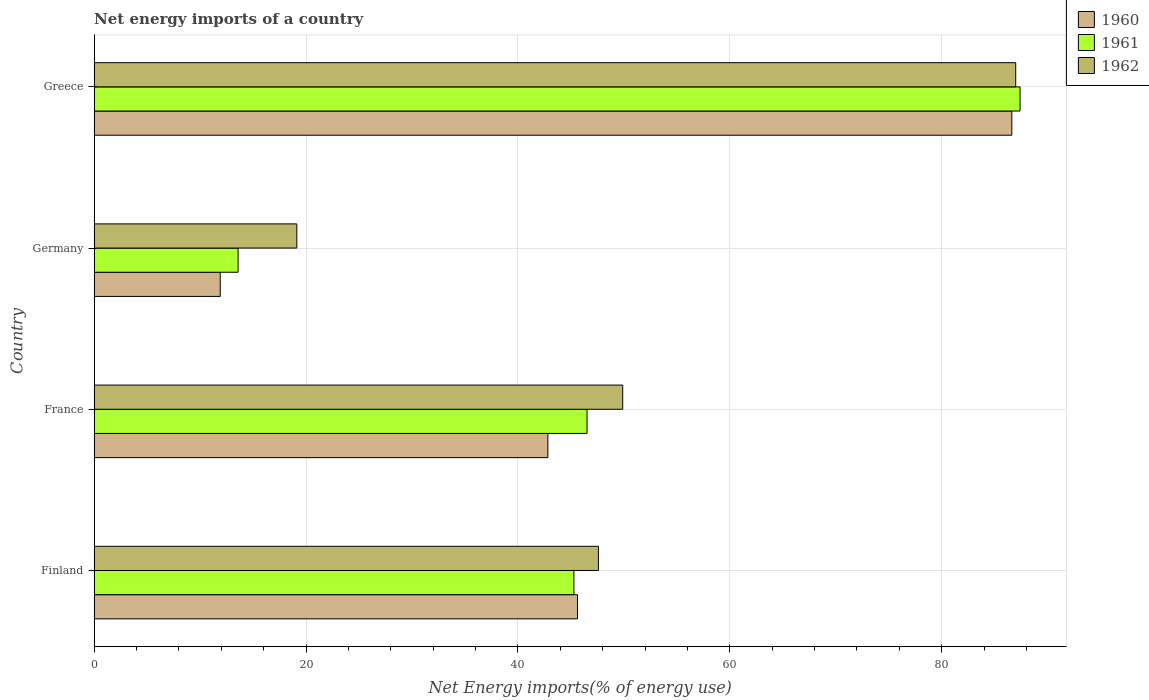How many different coloured bars are there?
Your answer should be compact. 3. How many groups of bars are there?
Make the answer very short. 4. Are the number of bars per tick equal to the number of legend labels?
Give a very brief answer. Yes. Are the number of bars on each tick of the Y-axis equal?
Your answer should be compact. Yes. How many bars are there on the 3rd tick from the top?
Ensure brevity in your answer.  3. In how many cases, is the number of bars for a given country not equal to the number of legend labels?
Your answer should be very brief. 0. What is the net energy imports in 1961 in Finland?
Your answer should be compact. 45.28. Across all countries, what is the maximum net energy imports in 1962?
Offer a very short reply. 86.98. Across all countries, what is the minimum net energy imports in 1961?
Provide a succinct answer. 13.58. In which country was the net energy imports in 1960 maximum?
Ensure brevity in your answer.  Greece. In which country was the net energy imports in 1960 minimum?
Your response must be concise. Germany. What is the total net energy imports in 1960 in the graph?
Provide a succinct answer. 186.96. What is the difference between the net energy imports in 1961 in France and that in Greece?
Ensure brevity in your answer.  -40.87. What is the difference between the net energy imports in 1962 in France and the net energy imports in 1961 in Finland?
Provide a succinct answer. 4.61. What is the average net energy imports in 1960 per country?
Make the answer very short. 46.74. What is the difference between the net energy imports in 1960 and net energy imports in 1962 in Finland?
Provide a short and direct response. -1.97. In how many countries, is the net energy imports in 1961 greater than 24 %?
Your response must be concise. 3. What is the ratio of the net energy imports in 1962 in France to that in Greece?
Offer a very short reply. 0.57. What is the difference between the highest and the second highest net energy imports in 1960?
Offer a very short reply. 41. What is the difference between the highest and the lowest net energy imports in 1961?
Offer a terse response. 73.81. What does the 3rd bar from the top in Germany represents?
Your answer should be very brief. 1960. Is it the case that in every country, the sum of the net energy imports in 1960 and net energy imports in 1961 is greater than the net energy imports in 1962?
Your answer should be compact. Yes. Are all the bars in the graph horizontal?
Provide a succinct answer. Yes. How many countries are there in the graph?
Give a very brief answer. 4. What is the difference between two consecutive major ticks on the X-axis?
Provide a short and direct response. 20. Are the values on the major ticks of X-axis written in scientific E-notation?
Ensure brevity in your answer.  No. Does the graph contain any zero values?
Offer a very short reply. No. Does the graph contain grids?
Offer a very short reply. Yes. How are the legend labels stacked?
Ensure brevity in your answer.  Vertical. What is the title of the graph?
Offer a very short reply. Net energy imports of a country. Does "1976" appear as one of the legend labels in the graph?
Give a very brief answer. No. What is the label or title of the X-axis?
Provide a short and direct response. Net Energy imports(% of energy use). What is the label or title of the Y-axis?
Offer a very short reply. Country. What is the Net Energy imports(% of energy use) of 1960 in Finland?
Offer a terse response. 45.62. What is the Net Energy imports(% of energy use) in 1961 in Finland?
Your answer should be compact. 45.28. What is the Net Energy imports(% of energy use) of 1962 in Finland?
Your answer should be compact. 47.59. What is the Net Energy imports(% of energy use) in 1960 in France?
Ensure brevity in your answer.  42.82. What is the Net Energy imports(% of energy use) in 1961 in France?
Make the answer very short. 46.52. What is the Net Energy imports(% of energy use) of 1962 in France?
Offer a terse response. 49.89. What is the Net Energy imports(% of energy use) in 1960 in Germany?
Your answer should be compact. 11.9. What is the Net Energy imports(% of energy use) of 1961 in Germany?
Your answer should be compact. 13.58. What is the Net Energy imports(% of energy use) in 1962 in Germany?
Keep it short and to the point. 19.13. What is the Net Energy imports(% of energy use) of 1960 in Greece?
Offer a terse response. 86.62. What is the Net Energy imports(% of energy use) in 1961 in Greece?
Offer a terse response. 87.4. What is the Net Energy imports(% of energy use) in 1962 in Greece?
Provide a short and direct response. 86.98. Across all countries, what is the maximum Net Energy imports(% of energy use) of 1960?
Provide a short and direct response. 86.62. Across all countries, what is the maximum Net Energy imports(% of energy use) in 1961?
Provide a succinct answer. 87.4. Across all countries, what is the maximum Net Energy imports(% of energy use) in 1962?
Offer a very short reply. 86.98. Across all countries, what is the minimum Net Energy imports(% of energy use) of 1960?
Keep it short and to the point. 11.9. Across all countries, what is the minimum Net Energy imports(% of energy use) in 1961?
Your response must be concise. 13.58. Across all countries, what is the minimum Net Energy imports(% of energy use) of 1962?
Your answer should be very brief. 19.13. What is the total Net Energy imports(% of energy use) of 1960 in the graph?
Your answer should be very brief. 186.96. What is the total Net Energy imports(% of energy use) in 1961 in the graph?
Give a very brief answer. 192.78. What is the total Net Energy imports(% of energy use) in 1962 in the graph?
Provide a short and direct response. 203.59. What is the difference between the Net Energy imports(% of energy use) of 1960 in Finland and that in France?
Your answer should be compact. 2.8. What is the difference between the Net Energy imports(% of energy use) of 1961 in Finland and that in France?
Your answer should be compact. -1.24. What is the difference between the Net Energy imports(% of energy use) in 1962 in Finland and that in France?
Give a very brief answer. -2.3. What is the difference between the Net Energy imports(% of energy use) of 1960 in Finland and that in Germany?
Make the answer very short. 33.72. What is the difference between the Net Energy imports(% of energy use) of 1961 in Finland and that in Germany?
Keep it short and to the point. 31.7. What is the difference between the Net Energy imports(% of energy use) in 1962 in Finland and that in Germany?
Your answer should be compact. 28.47. What is the difference between the Net Energy imports(% of energy use) in 1960 in Finland and that in Greece?
Your response must be concise. -41. What is the difference between the Net Energy imports(% of energy use) in 1961 in Finland and that in Greece?
Your response must be concise. -42.12. What is the difference between the Net Energy imports(% of energy use) of 1962 in Finland and that in Greece?
Offer a terse response. -39.39. What is the difference between the Net Energy imports(% of energy use) in 1960 in France and that in Germany?
Give a very brief answer. 30.93. What is the difference between the Net Energy imports(% of energy use) in 1961 in France and that in Germany?
Offer a terse response. 32.94. What is the difference between the Net Energy imports(% of energy use) in 1962 in France and that in Germany?
Provide a succinct answer. 30.76. What is the difference between the Net Energy imports(% of energy use) of 1960 in France and that in Greece?
Provide a succinct answer. -43.79. What is the difference between the Net Energy imports(% of energy use) in 1961 in France and that in Greece?
Offer a terse response. -40.87. What is the difference between the Net Energy imports(% of energy use) in 1962 in France and that in Greece?
Your answer should be very brief. -37.09. What is the difference between the Net Energy imports(% of energy use) of 1960 in Germany and that in Greece?
Offer a very short reply. -74.72. What is the difference between the Net Energy imports(% of energy use) of 1961 in Germany and that in Greece?
Your answer should be very brief. -73.81. What is the difference between the Net Energy imports(% of energy use) in 1962 in Germany and that in Greece?
Keep it short and to the point. -67.86. What is the difference between the Net Energy imports(% of energy use) of 1960 in Finland and the Net Energy imports(% of energy use) of 1961 in France?
Your response must be concise. -0.9. What is the difference between the Net Energy imports(% of energy use) of 1960 in Finland and the Net Energy imports(% of energy use) of 1962 in France?
Your response must be concise. -4.27. What is the difference between the Net Energy imports(% of energy use) of 1961 in Finland and the Net Energy imports(% of energy use) of 1962 in France?
Make the answer very short. -4.61. What is the difference between the Net Energy imports(% of energy use) in 1960 in Finland and the Net Energy imports(% of energy use) in 1961 in Germany?
Your answer should be compact. 32.04. What is the difference between the Net Energy imports(% of energy use) in 1960 in Finland and the Net Energy imports(% of energy use) in 1962 in Germany?
Keep it short and to the point. 26.49. What is the difference between the Net Energy imports(% of energy use) of 1961 in Finland and the Net Energy imports(% of energy use) of 1962 in Germany?
Your answer should be very brief. 26.15. What is the difference between the Net Energy imports(% of energy use) in 1960 in Finland and the Net Energy imports(% of energy use) in 1961 in Greece?
Offer a terse response. -41.78. What is the difference between the Net Energy imports(% of energy use) of 1960 in Finland and the Net Energy imports(% of energy use) of 1962 in Greece?
Ensure brevity in your answer.  -41.36. What is the difference between the Net Energy imports(% of energy use) of 1961 in Finland and the Net Energy imports(% of energy use) of 1962 in Greece?
Offer a terse response. -41.7. What is the difference between the Net Energy imports(% of energy use) of 1960 in France and the Net Energy imports(% of energy use) of 1961 in Germany?
Your response must be concise. 29.24. What is the difference between the Net Energy imports(% of energy use) of 1960 in France and the Net Energy imports(% of energy use) of 1962 in Germany?
Keep it short and to the point. 23.7. What is the difference between the Net Energy imports(% of energy use) in 1961 in France and the Net Energy imports(% of energy use) in 1962 in Germany?
Provide a succinct answer. 27.39. What is the difference between the Net Energy imports(% of energy use) of 1960 in France and the Net Energy imports(% of energy use) of 1961 in Greece?
Your answer should be very brief. -44.57. What is the difference between the Net Energy imports(% of energy use) in 1960 in France and the Net Energy imports(% of energy use) in 1962 in Greece?
Give a very brief answer. -44.16. What is the difference between the Net Energy imports(% of energy use) in 1961 in France and the Net Energy imports(% of energy use) in 1962 in Greece?
Keep it short and to the point. -40.46. What is the difference between the Net Energy imports(% of energy use) in 1960 in Germany and the Net Energy imports(% of energy use) in 1961 in Greece?
Offer a terse response. -75.5. What is the difference between the Net Energy imports(% of energy use) in 1960 in Germany and the Net Energy imports(% of energy use) in 1962 in Greece?
Keep it short and to the point. -75.08. What is the difference between the Net Energy imports(% of energy use) of 1961 in Germany and the Net Energy imports(% of energy use) of 1962 in Greece?
Offer a very short reply. -73.4. What is the average Net Energy imports(% of energy use) in 1960 per country?
Keep it short and to the point. 46.74. What is the average Net Energy imports(% of energy use) in 1961 per country?
Your answer should be very brief. 48.19. What is the average Net Energy imports(% of energy use) in 1962 per country?
Your answer should be very brief. 50.9. What is the difference between the Net Energy imports(% of energy use) of 1960 and Net Energy imports(% of energy use) of 1961 in Finland?
Provide a short and direct response. 0.34. What is the difference between the Net Energy imports(% of energy use) of 1960 and Net Energy imports(% of energy use) of 1962 in Finland?
Make the answer very short. -1.97. What is the difference between the Net Energy imports(% of energy use) in 1961 and Net Energy imports(% of energy use) in 1962 in Finland?
Provide a succinct answer. -2.31. What is the difference between the Net Energy imports(% of energy use) in 1960 and Net Energy imports(% of energy use) in 1961 in France?
Provide a succinct answer. -3.7. What is the difference between the Net Energy imports(% of energy use) of 1960 and Net Energy imports(% of energy use) of 1962 in France?
Ensure brevity in your answer.  -7.06. What is the difference between the Net Energy imports(% of energy use) in 1961 and Net Energy imports(% of energy use) in 1962 in France?
Provide a short and direct response. -3.37. What is the difference between the Net Energy imports(% of energy use) in 1960 and Net Energy imports(% of energy use) in 1961 in Germany?
Ensure brevity in your answer.  -1.68. What is the difference between the Net Energy imports(% of energy use) of 1960 and Net Energy imports(% of energy use) of 1962 in Germany?
Offer a terse response. -7.23. What is the difference between the Net Energy imports(% of energy use) of 1961 and Net Energy imports(% of energy use) of 1962 in Germany?
Provide a succinct answer. -5.54. What is the difference between the Net Energy imports(% of energy use) in 1960 and Net Energy imports(% of energy use) in 1961 in Greece?
Provide a short and direct response. -0.78. What is the difference between the Net Energy imports(% of energy use) in 1960 and Net Energy imports(% of energy use) in 1962 in Greece?
Provide a succinct answer. -0.37. What is the difference between the Net Energy imports(% of energy use) in 1961 and Net Energy imports(% of energy use) in 1962 in Greece?
Keep it short and to the point. 0.41. What is the ratio of the Net Energy imports(% of energy use) of 1960 in Finland to that in France?
Your response must be concise. 1.07. What is the ratio of the Net Energy imports(% of energy use) of 1961 in Finland to that in France?
Offer a terse response. 0.97. What is the ratio of the Net Energy imports(% of energy use) in 1962 in Finland to that in France?
Make the answer very short. 0.95. What is the ratio of the Net Energy imports(% of energy use) in 1960 in Finland to that in Germany?
Your response must be concise. 3.83. What is the ratio of the Net Energy imports(% of energy use) of 1961 in Finland to that in Germany?
Provide a succinct answer. 3.33. What is the ratio of the Net Energy imports(% of energy use) in 1962 in Finland to that in Germany?
Make the answer very short. 2.49. What is the ratio of the Net Energy imports(% of energy use) in 1960 in Finland to that in Greece?
Keep it short and to the point. 0.53. What is the ratio of the Net Energy imports(% of energy use) in 1961 in Finland to that in Greece?
Provide a succinct answer. 0.52. What is the ratio of the Net Energy imports(% of energy use) in 1962 in Finland to that in Greece?
Ensure brevity in your answer.  0.55. What is the ratio of the Net Energy imports(% of energy use) of 1960 in France to that in Germany?
Provide a short and direct response. 3.6. What is the ratio of the Net Energy imports(% of energy use) in 1961 in France to that in Germany?
Your response must be concise. 3.43. What is the ratio of the Net Energy imports(% of energy use) in 1962 in France to that in Germany?
Provide a short and direct response. 2.61. What is the ratio of the Net Energy imports(% of energy use) in 1960 in France to that in Greece?
Offer a terse response. 0.49. What is the ratio of the Net Energy imports(% of energy use) of 1961 in France to that in Greece?
Provide a succinct answer. 0.53. What is the ratio of the Net Energy imports(% of energy use) in 1962 in France to that in Greece?
Make the answer very short. 0.57. What is the ratio of the Net Energy imports(% of energy use) of 1960 in Germany to that in Greece?
Make the answer very short. 0.14. What is the ratio of the Net Energy imports(% of energy use) in 1961 in Germany to that in Greece?
Your answer should be compact. 0.16. What is the ratio of the Net Energy imports(% of energy use) of 1962 in Germany to that in Greece?
Offer a terse response. 0.22. What is the difference between the highest and the second highest Net Energy imports(% of energy use) in 1960?
Your answer should be compact. 41. What is the difference between the highest and the second highest Net Energy imports(% of energy use) of 1961?
Your response must be concise. 40.87. What is the difference between the highest and the second highest Net Energy imports(% of energy use) in 1962?
Your response must be concise. 37.09. What is the difference between the highest and the lowest Net Energy imports(% of energy use) of 1960?
Give a very brief answer. 74.72. What is the difference between the highest and the lowest Net Energy imports(% of energy use) of 1961?
Keep it short and to the point. 73.81. What is the difference between the highest and the lowest Net Energy imports(% of energy use) of 1962?
Give a very brief answer. 67.86. 